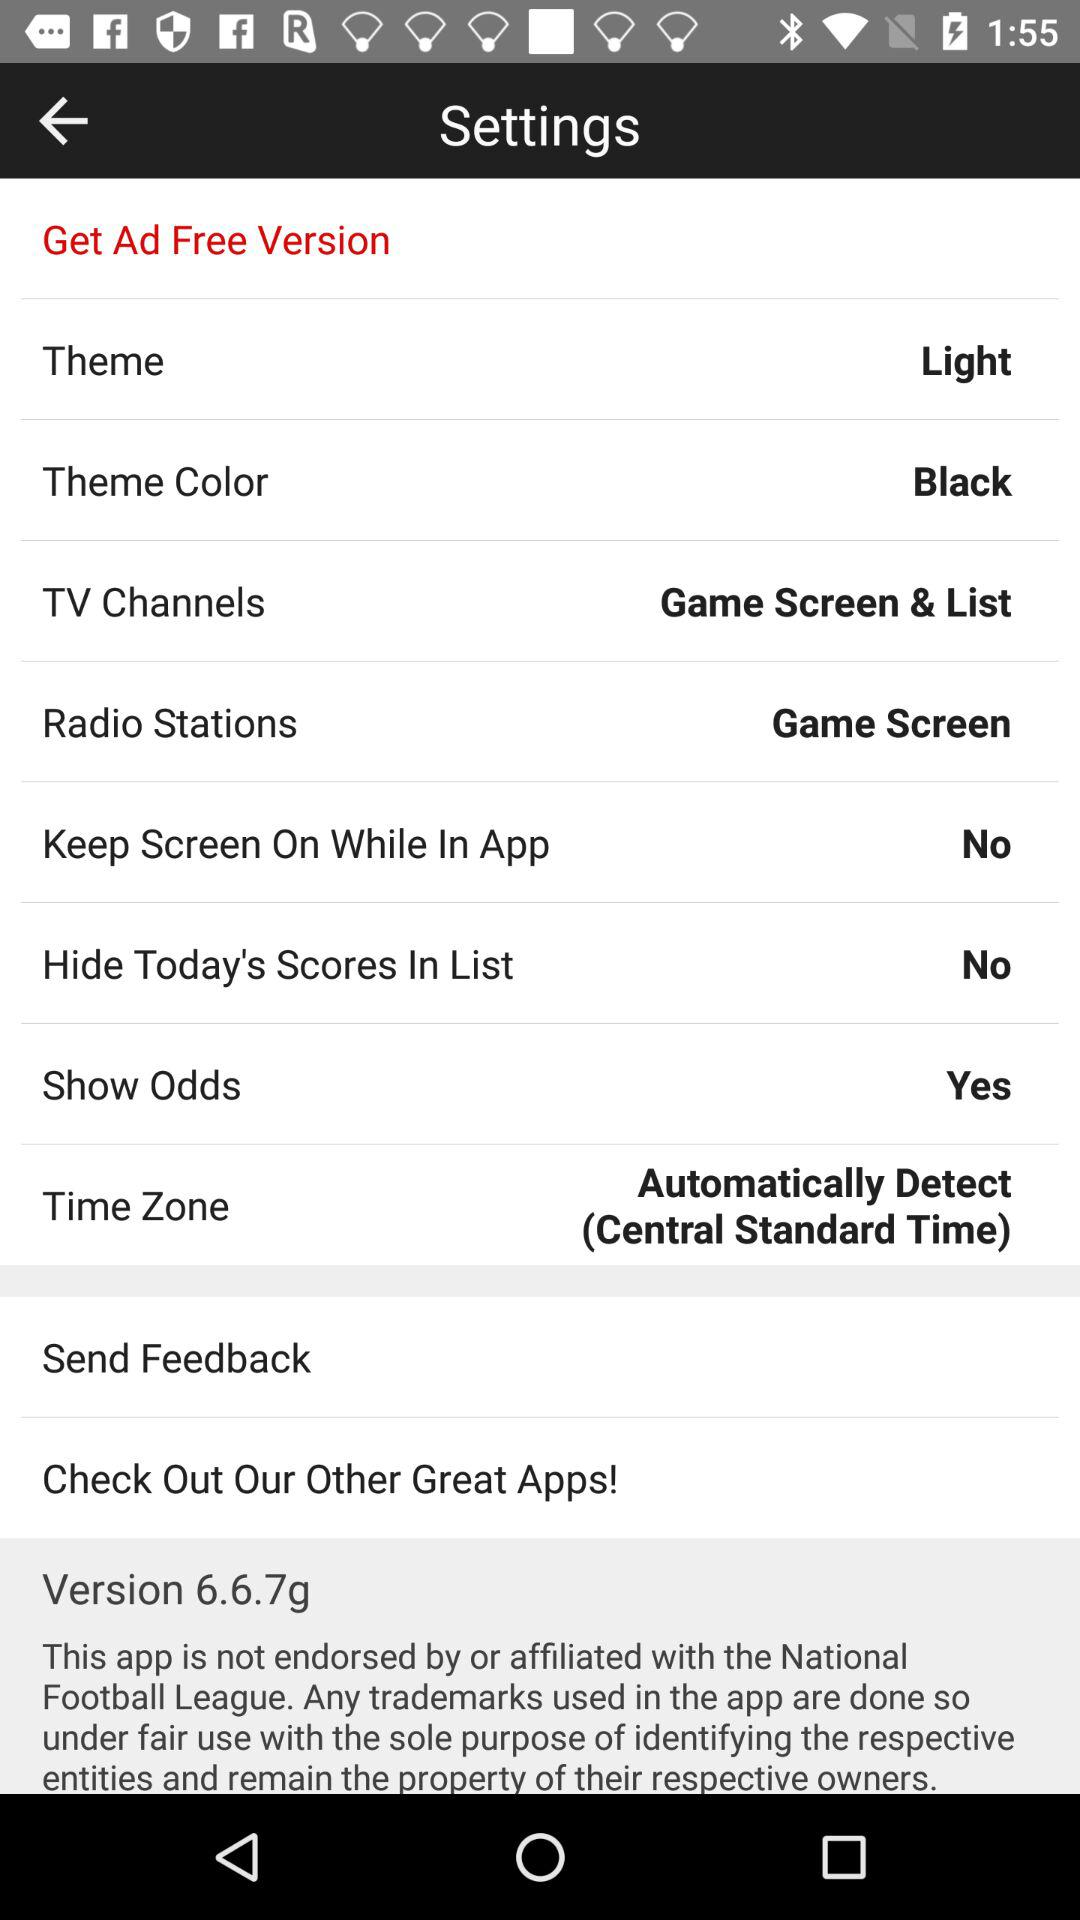What is the version number? The version number is 6.6.7g. 